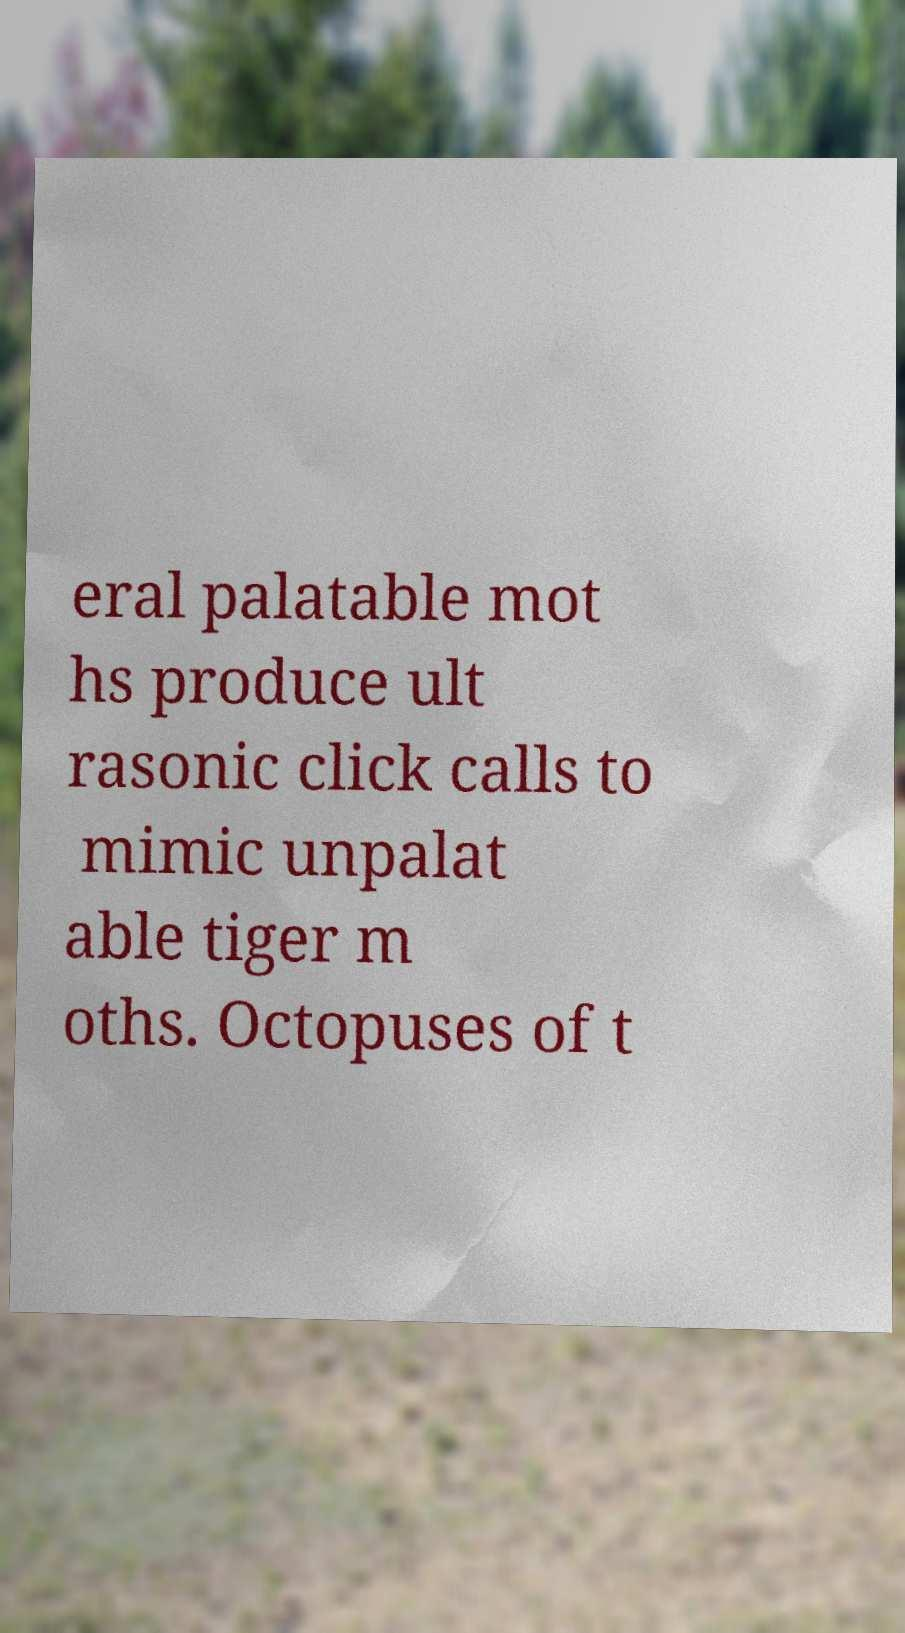Please read and relay the text visible in this image. What does it say? eral palatable mot hs produce ult rasonic click calls to mimic unpalat able tiger m oths. Octopuses of t 